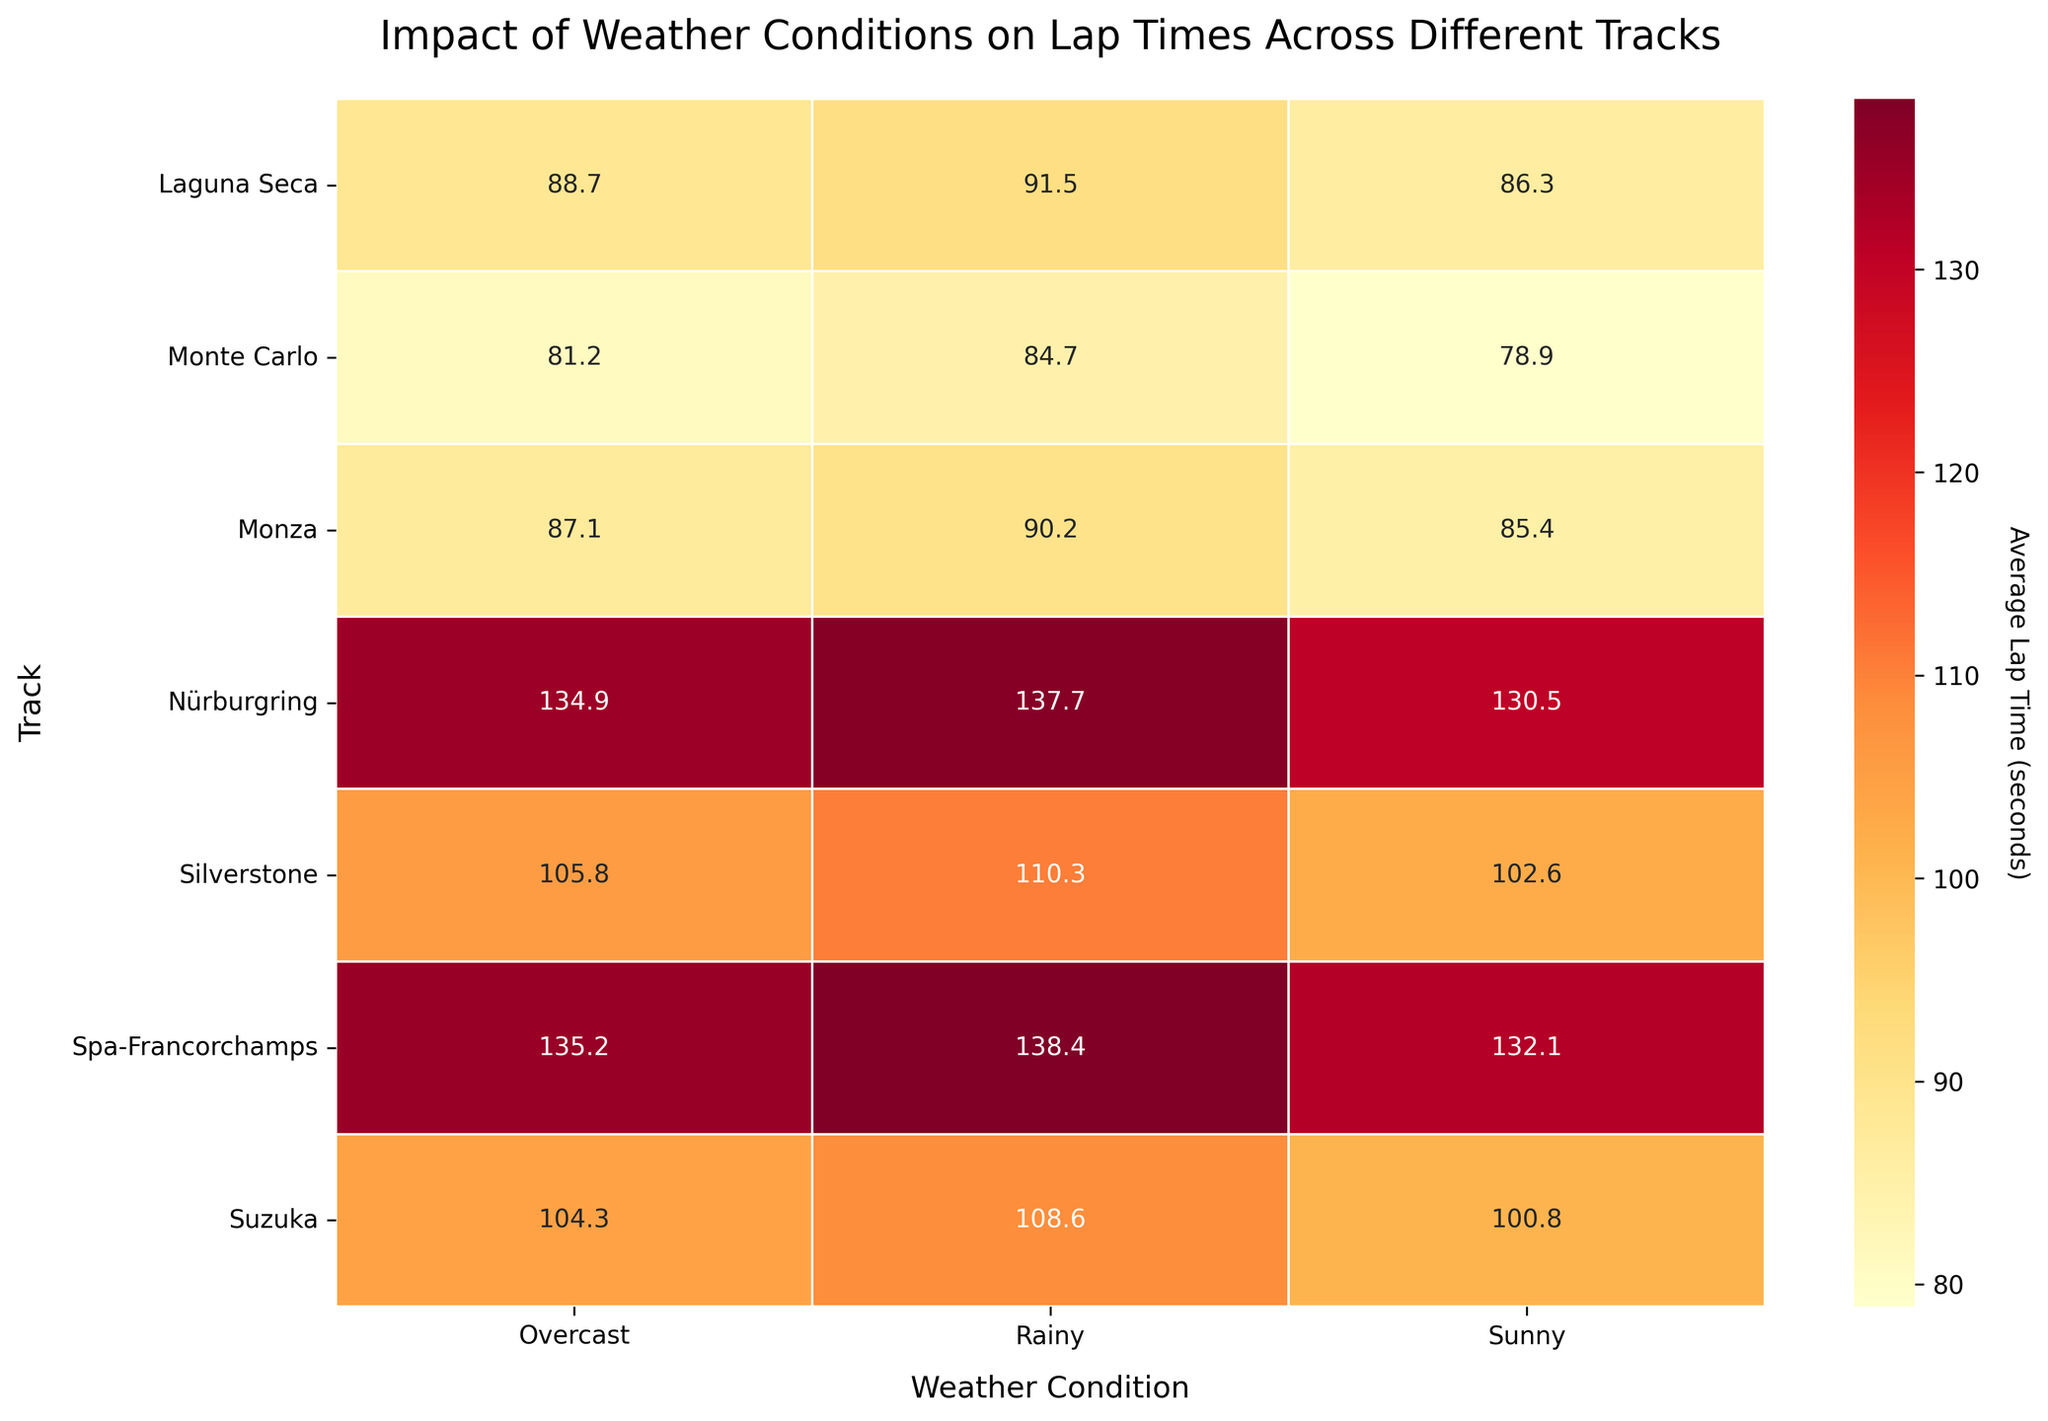What is the title of the plot? The title is located at the top of the plot and is clearly displayed.
Answer: Impact of Weather Conditions on Lap Times Across Different Tracks Which track has the highest average lap time in rainy conditions? Look for the highest value in the "Rainy" column.
Answer: Nürburgring What is the average lap time on Silverstone when it is overcast? Find the value in the Silverstone row and Overcast column.
Answer: 105.8 How much slower is the lap time on Suzuka in rainy conditions compared to sunny conditions? Subtract the average lap time in sunny conditions from the average lap time in rainy conditions for Suzuka. 108.6 - 100.8 = 7.8 seconds.
Answer: 7.8 seconds Which track shows the least difference in lap times between sunny and overcast conditions? Subtract the sunny column values from the overcast column values for all tracks, identify the smallest difference. Monte Carlo: 81.2 - 78.9 = 2.3.
Answer: Monte Carlo Compare the average lap times for sunny conditions: which track has the fastest lap time and which one has the slowest? Look at the values in the "Sunny" column, find the minimum and maximum values. Fastest: Monte Carlo (78.9), Slowest: Nürburgring (130.5).
Answer: Fastest: Monte Carlo, Slowest: Nürburgring What is the average lap time for Nürburgring across all weather conditions? Sum the lap times for Nürburgring (130.5 + 137.7 + 134.9) and divide by 3. (130.5 + 137.7 + 134.9) / 3 = 134.37.
Answer: 134.37 seconds Which track experiences the greatest impact on lap times due to rain compared to sunny conditions? Calculate the difference between rainy and sunny lap times for each track, find the maximum difference. Silverstone: 110.3 - 102.6 = 7.7, Monza: 90.2 - 85.4 = 4.8, Nürburgring: 137.7 - 130.5 = 7.2, Spa-Francorchamps: 138.4 - 132.1 = 6.3, Laguna Seca: 91.5 - 86.3 = 5.2, Suzuka: 108.6 - 100.8 = 7.8, Monte Carlo: 84.7 - 78.9 = 5.8.
Answer: Suzuka What is the median lap time for Spa-Francorchamps in different weather conditions? Sort the lap times for Spa-Francorchamps and find the middle value. The sorted times are (132.1, 135.2, 138.4), so the median is 135.2.
Answer: 135.2 seconds 